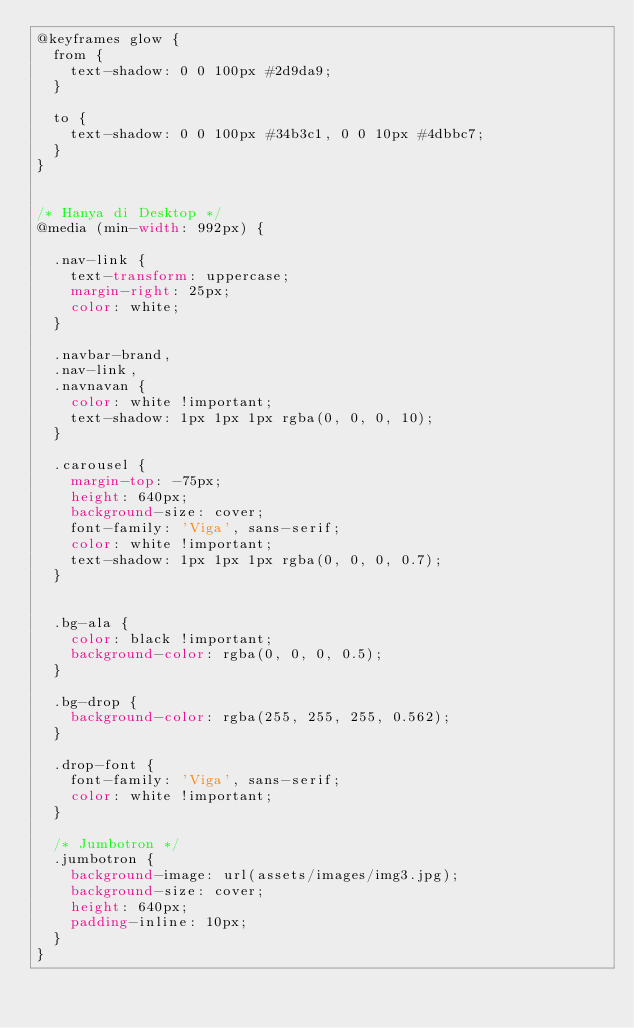<code> <loc_0><loc_0><loc_500><loc_500><_CSS_>@keyframes glow {
	from {
		text-shadow: 0 0 100px #2d9da9;
	}

	to {
		text-shadow: 0 0 100px #34b3c1, 0 0 10px #4dbbc7;
	}
}


/* Hanya di Desktop */
@media (min-width: 992px) {

	.nav-link {
		text-transform: uppercase;
		margin-right: 25px;
		color: white;
	}

	.navbar-brand,
	.nav-link,
	.navnavan {
		color: white !important;
		text-shadow: 1px 1px 1px rgba(0, 0, 0, 10);
	}

	.carousel {
		margin-top: -75px;
		height: 640px;
		background-size: cover;
		font-family: 'Viga', sans-serif;
		color: white !important;
		text-shadow: 1px 1px 1px rgba(0, 0, 0, 0.7);
	}


	.bg-ala {
		color: black !important;
		background-color: rgba(0, 0, 0, 0.5);
	}

	.bg-drop {
		background-color: rgba(255, 255, 255, 0.562);
	}

	.drop-font {
		font-family: 'Viga', sans-serif;
		color: white !important;
	}

	/* Jumbotron */
	.jumbotron {
		background-image: url(assets/images/img3.jpg);
		background-size: cover;
		height: 640px;
		padding-inline: 10px;
	}
}
</code> 